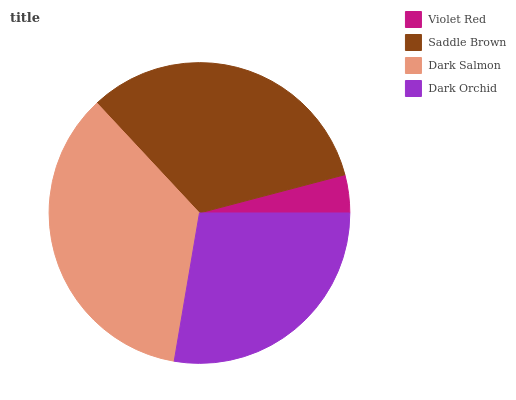Is Violet Red the minimum?
Answer yes or no. Yes. Is Dark Salmon the maximum?
Answer yes or no. Yes. Is Saddle Brown the minimum?
Answer yes or no. No. Is Saddle Brown the maximum?
Answer yes or no. No. Is Saddle Brown greater than Violet Red?
Answer yes or no. Yes. Is Violet Red less than Saddle Brown?
Answer yes or no. Yes. Is Violet Red greater than Saddle Brown?
Answer yes or no. No. Is Saddle Brown less than Violet Red?
Answer yes or no. No. Is Saddle Brown the high median?
Answer yes or no. Yes. Is Dark Orchid the low median?
Answer yes or no. Yes. Is Violet Red the high median?
Answer yes or no. No. Is Violet Red the low median?
Answer yes or no. No. 